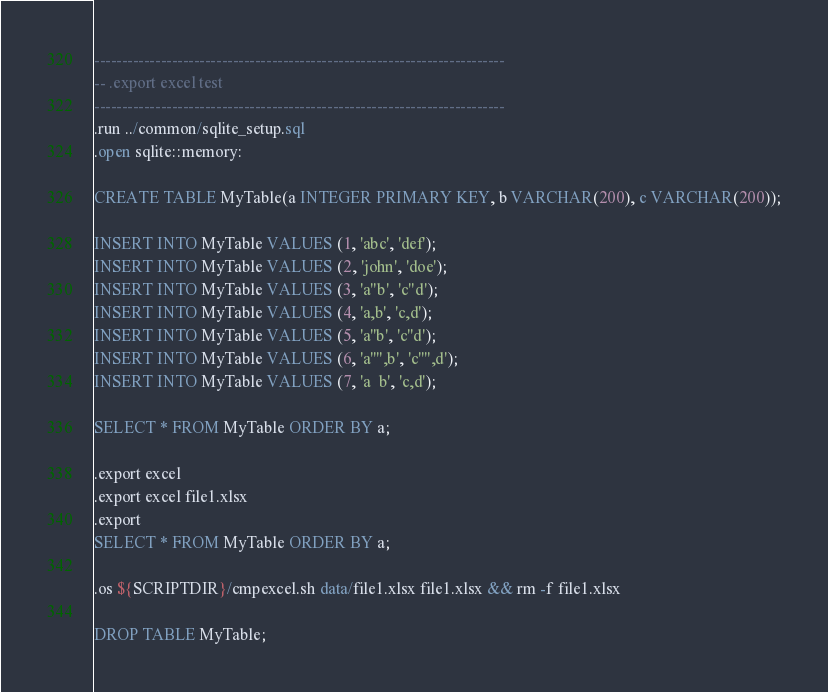<code> <loc_0><loc_0><loc_500><loc_500><_SQL_>--------------------------------------------------------------------------
-- .export excel test
--------------------------------------------------------------------------
.run ../common/sqlite_setup.sql
.open sqlite::memory:

CREATE TABLE MyTable(a INTEGER PRIMARY KEY, b VARCHAR(200), c VARCHAR(200));

INSERT INTO MyTable VALUES (1, 'abc', 'def');
INSERT INTO MyTable VALUES (2, 'john', 'doe');
INSERT INTO MyTable VALUES (3, 'a"b', 'c"d');
INSERT INTO MyTable VALUES (4, 'a,b', 'c,d');
INSERT INTO MyTable VALUES (5, 'a''b', 'c''d');
INSERT INTO MyTable VALUES (6, 'a''",b', 'c''",d');
INSERT INTO MyTable VALUES (7, 'a	b', 'c,d');

SELECT * FROM MyTable ORDER BY a;

.export excel
.export excel file1.xlsx
.export
SELECT * FROM MyTable ORDER BY a;

.os ${SCRIPTDIR}/cmpexcel.sh data/file1.xlsx file1.xlsx && rm -f file1.xlsx

DROP TABLE MyTable;

</code> 